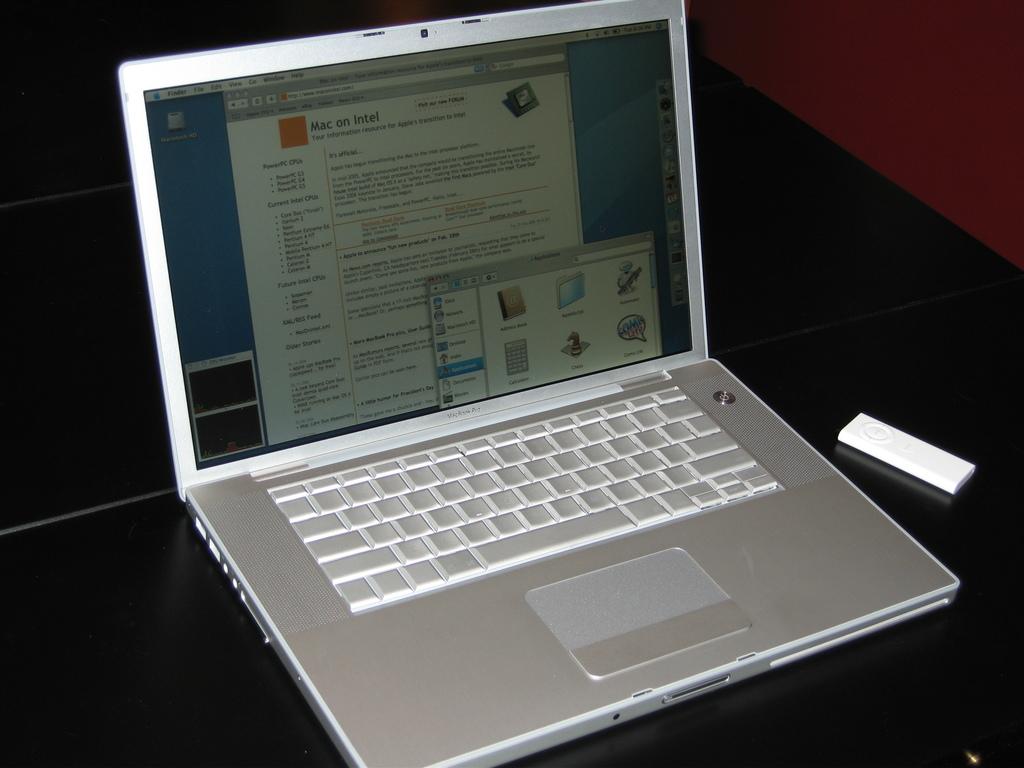What title is shown on screen?
Provide a succinct answer. Mac on intel. 